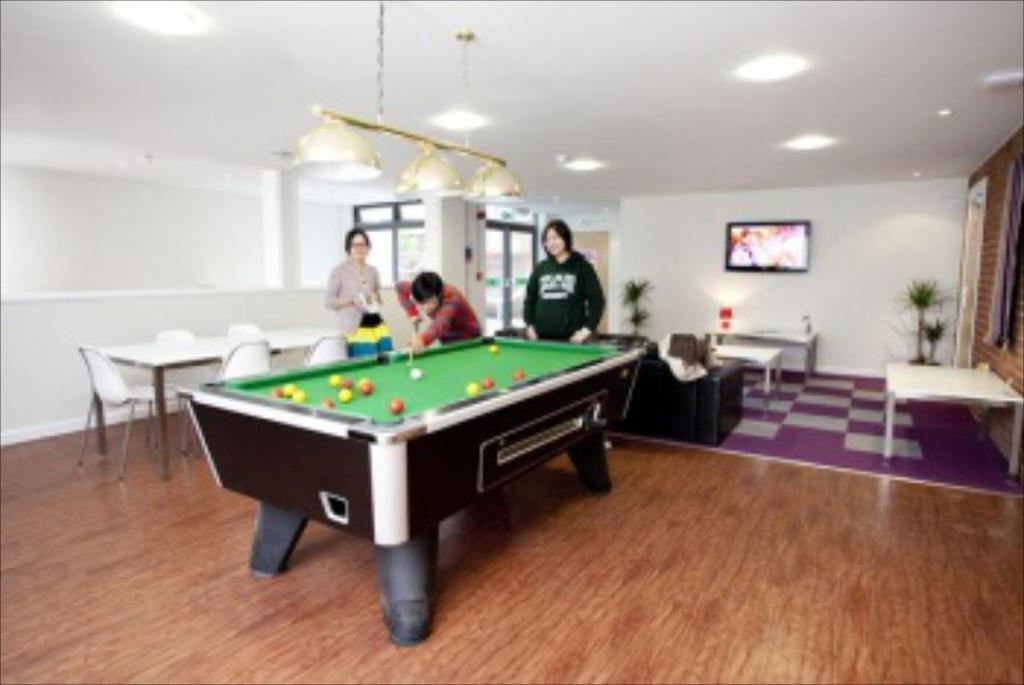How would you summarize this image in a sentence or two? As we can see in the image there is a white color wall, window, lights, screen, plants, chairs, tables and three people standing over. The man who is standing over here is playing billiards game. 